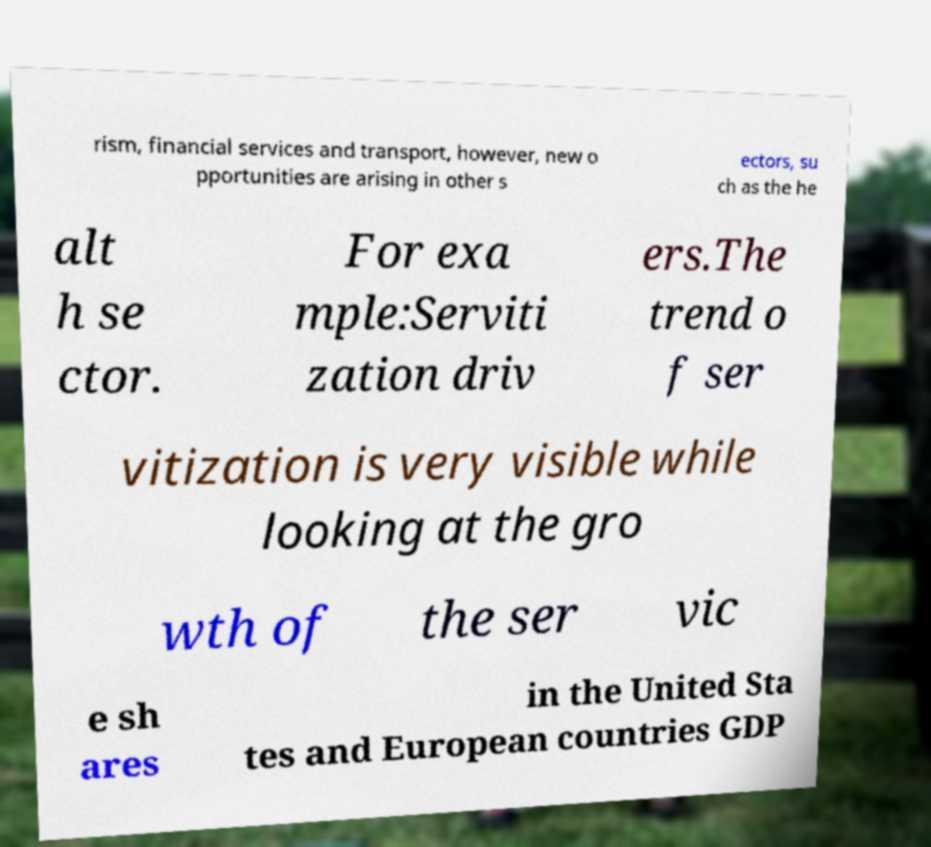Can you read and provide the text displayed in the image?This photo seems to have some interesting text. Can you extract and type it out for me? rism, financial services and transport, however, new o pportunities are arising in other s ectors, su ch as the he alt h se ctor. For exa mple:Serviti zation driv ers.The trend o f ser vitization is very visible while looking at the gro wth of the ser vic e sh ares in the United Sta tes and European countries GDP 